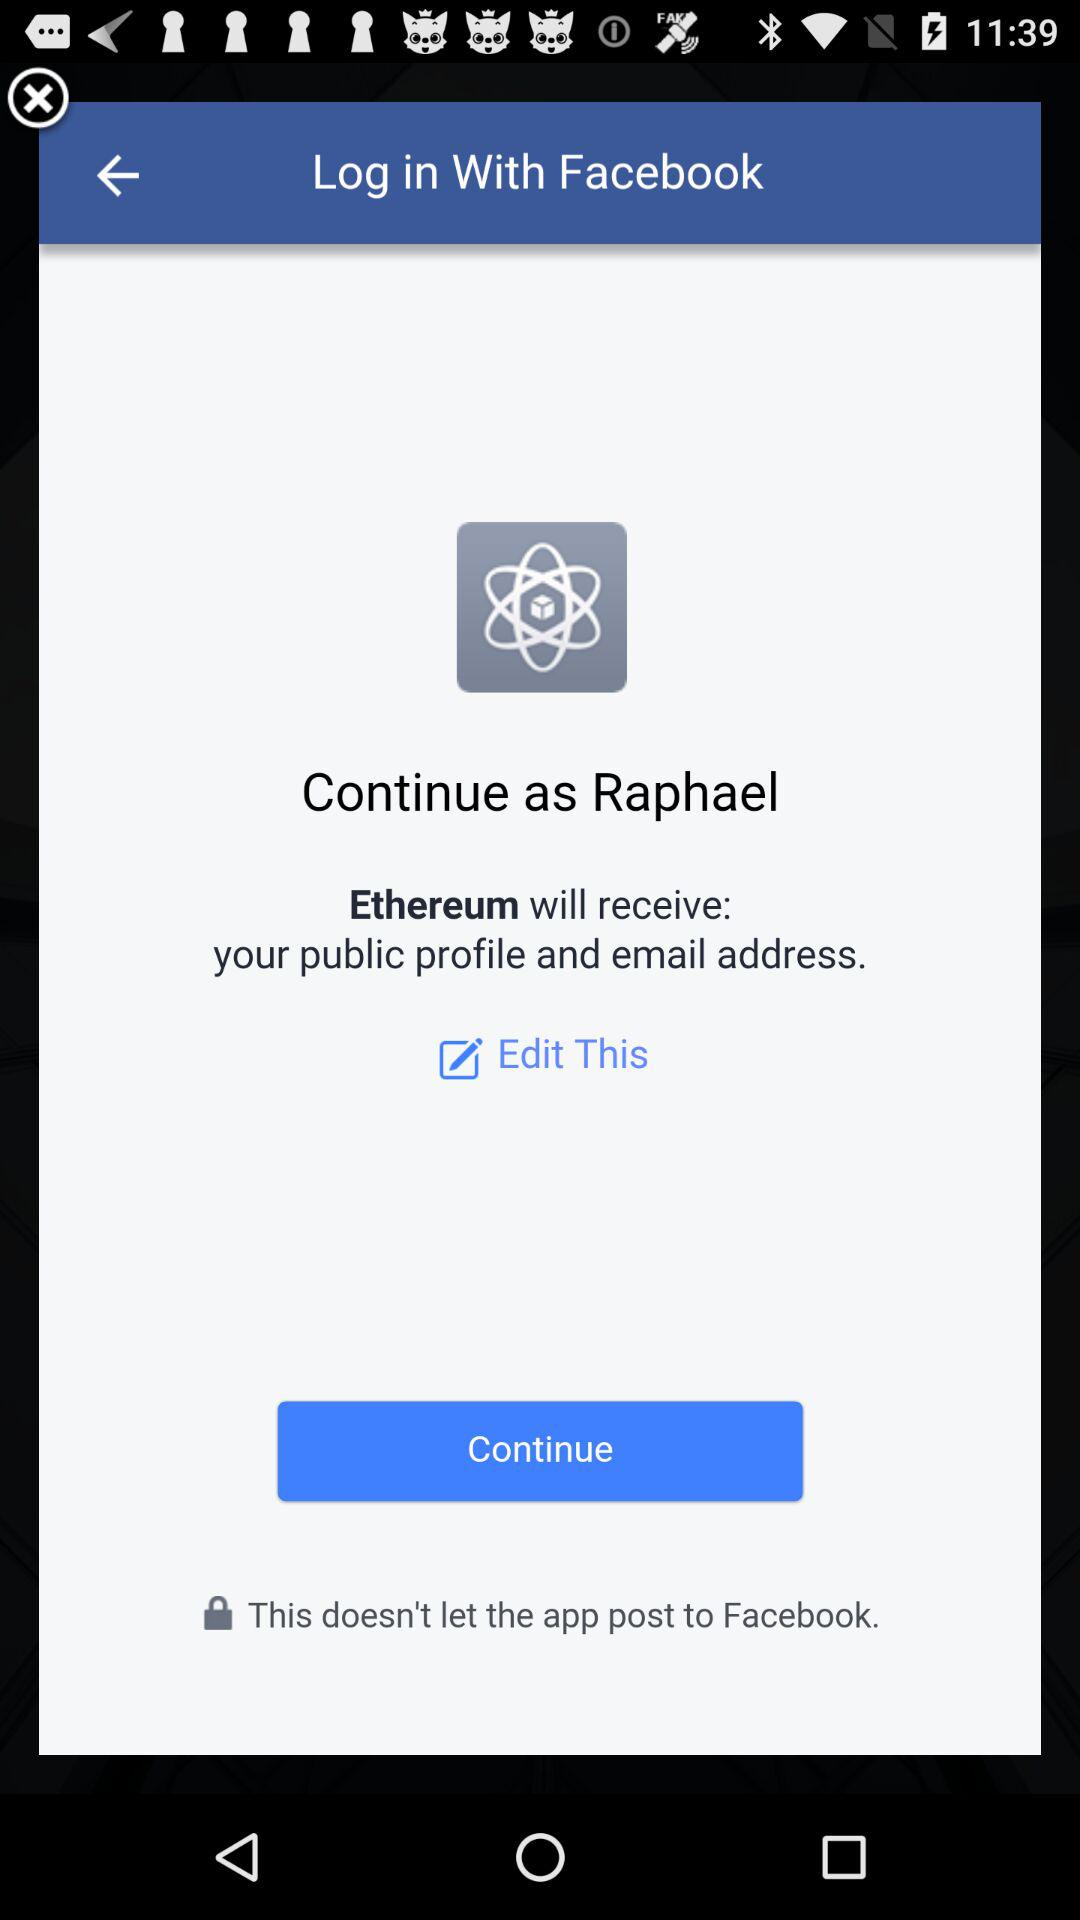What application will receive your public profile and email address? The application "Ethereum" will receive your public profile and email address. 